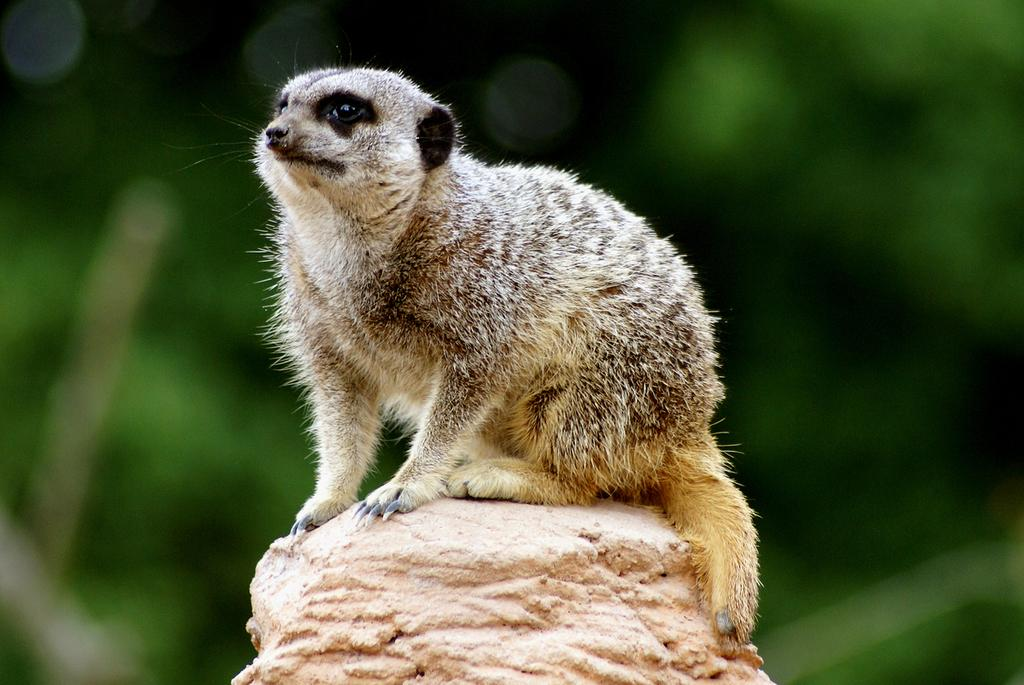What type of creature is in the image? There is an animal in the image. Where is the animal located? The animal is on a platform. Can you describe the background of the image? The background of the image is blurry. Is the animal reading a book in the image? There is no book or indication of reading in the image; it only features an animal on a platform with a blurry background. 